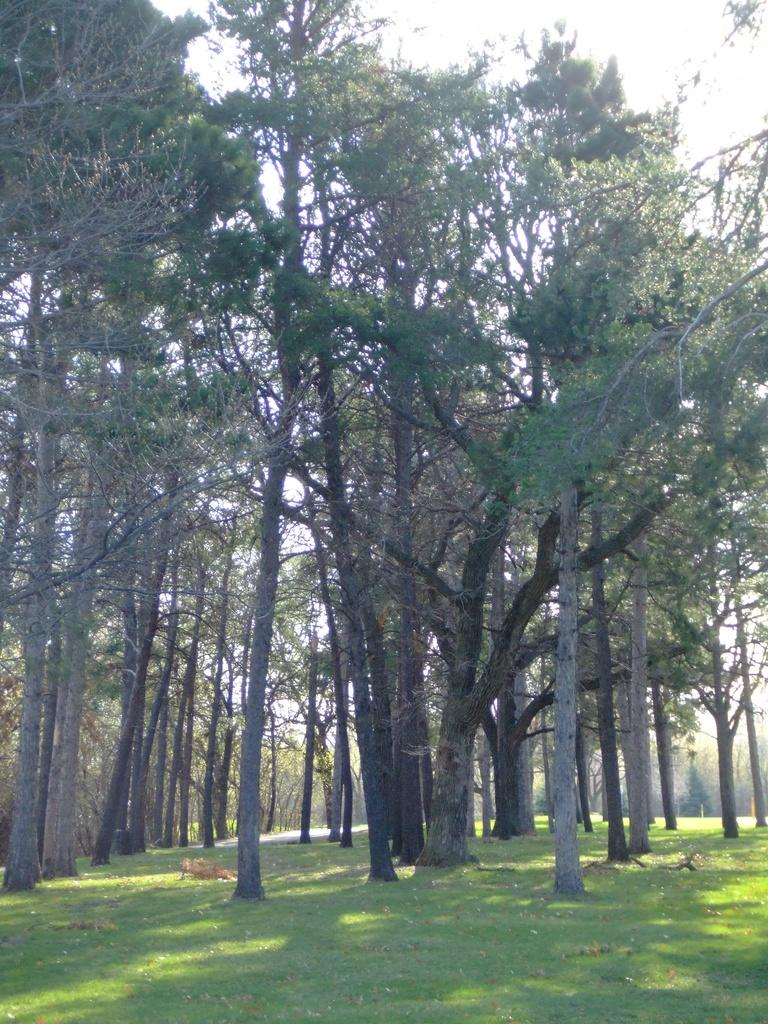What is visible on the ground in the image? The ground is visible in the image, and there is grass on the ground. What type of vegetation can be seen in the image? There are trees in the image. What colors are the trees in the image? The trees have green, brown, and ash colors. What is visible in the background of the image? The sky is visible in the background of the image. Can you see the sea in the image? No, the sea is not present in the image. The image features a grassy area with trees and a visible sky in the background. 